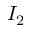Convert formula to latex. <formula><loc_0><loc_0><loc_500><loc_500>I _ { 2 }</formula> 